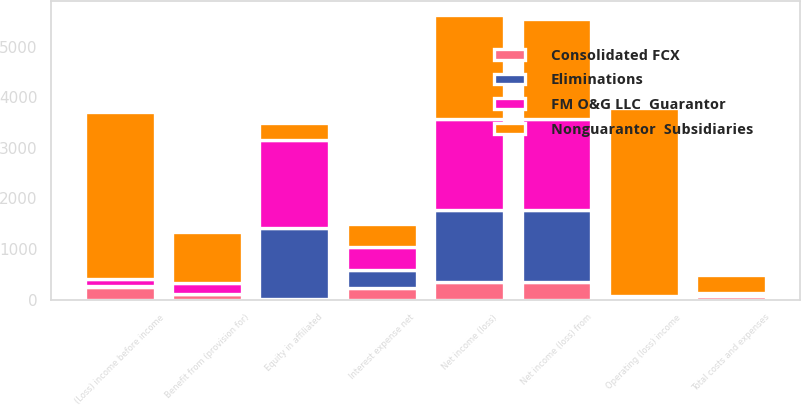Convert chart. <chart><loc_0><loc_0><loc_500><loc_500><stacked_bar_chart><ecel><fcel>Total costs and expenses<fcel>Operating (loss) income<fcel>Interest expense net<fcel>(Loss) income before income<fcel>Benefit from (provision for)<fcel>Equity in affiliated<fcel>Net income (loss) from<fcel>Net income (loss)<nl><fcel>FM O&G LLC  Guarantor<fcel>42<fcel>42<fcel>467<fcel>148<fcel>220<fcel>1745<fcel>1817<fcel>1817<nl><fcel>Consolidated FCX<fcel>78<fcel>26<fcel>227<fcel>248<fcel>108<fcel>10<fcel>346<fcel>346<nl><fcel>Nonguarantor  Subsidiaries<fcel>346<fcel>3711<fcel>455<fcel>3308<fcel>998<fcel>337<fcel>1973<fcel>2039<nl><fcel>Eliminations<fcel>10<fcel>10<fcel>348<fcel>10<fcel>3<fcel>1408<fcel>1415<fcel>1415<nl></chart> 